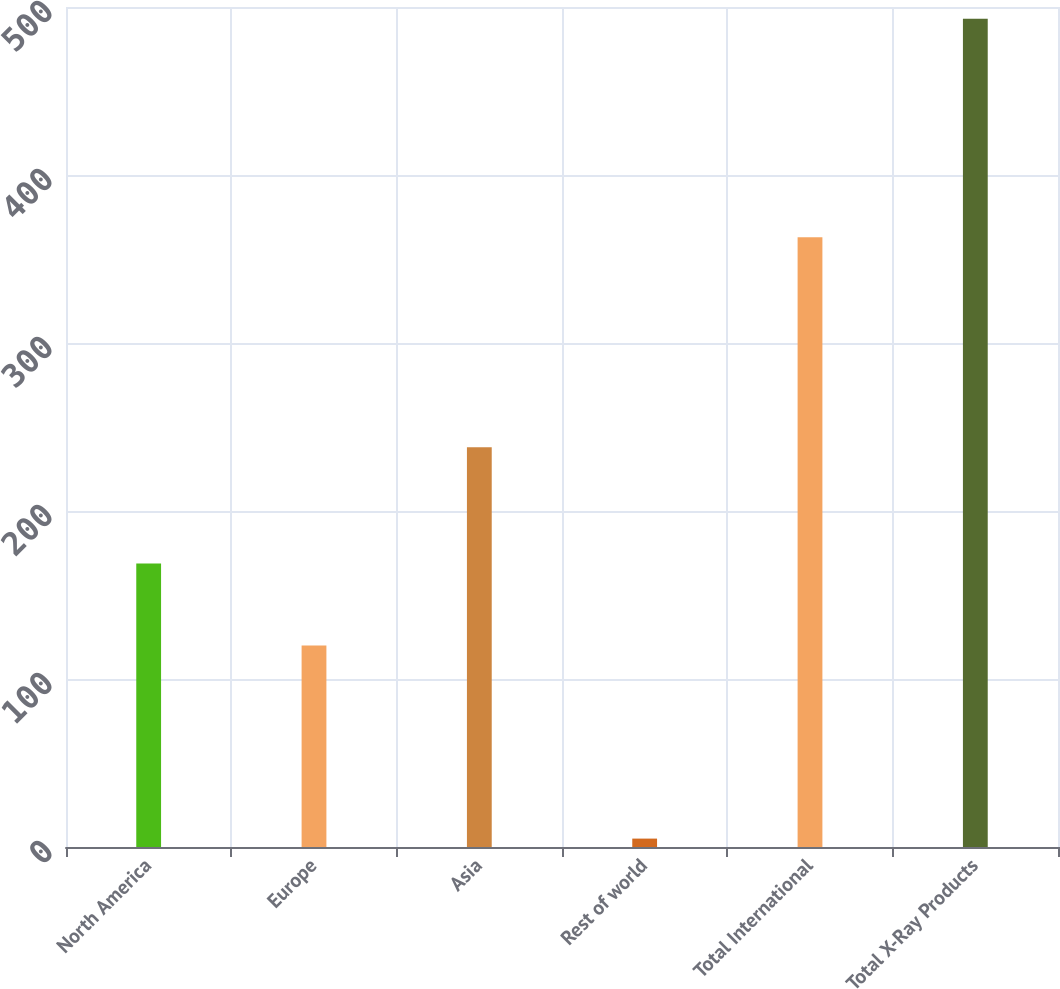Convert chart to OTSL. <chart><loc_0><loc_0><loc_500><loc_500><bar_chart><fcel>North America<fcel>Europe<fcel>Asia<fcel>Rest of world<fcel>Total International<fcel>Total X-Ray Products<nl><fcel>168.8<fcel>120<fcel>238<fcel>5<fcel>363<fcel>493<nl></chart> 